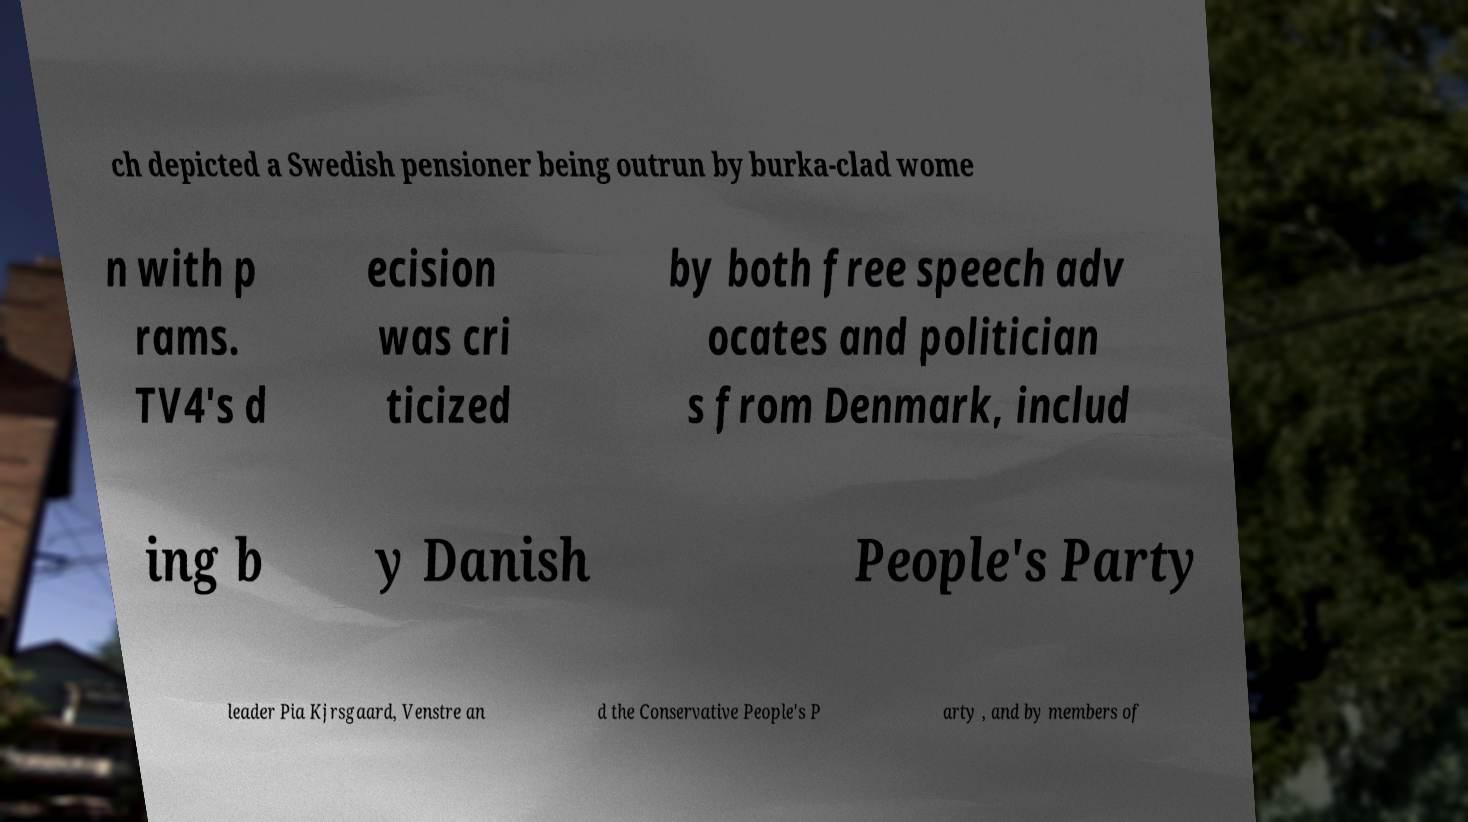There's text embedded in this image that I need extracted. Can you transcribe it verbatim? ch depicted a Swedish pensioner being outrun by burka-clad wome n with p rams. TV4's d ecision was cri ticized by both free speech adv ocates and politician s from Denmark, includ ing b y Danish People's Party leader Pia Kjrsgaard, Venstre an d the Conservative People's P arty , and by members of 